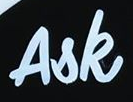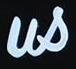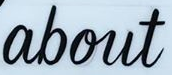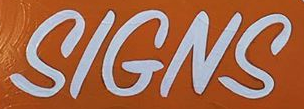Identify the words shown in these images in order, separated by a semicolon. Ask; us; about; SIGNS 